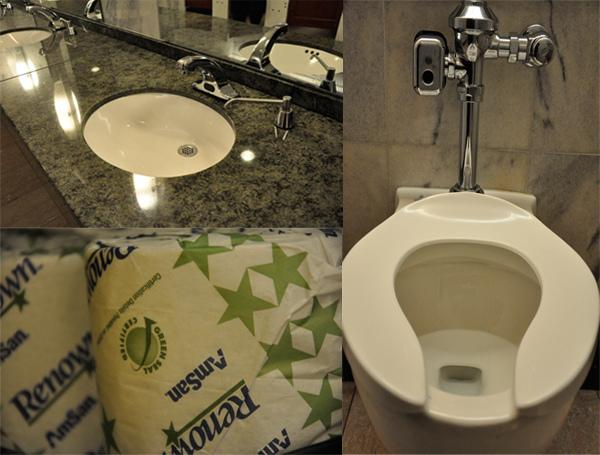How is the toilet flushed?

Choices:
A) pressure activated
B) ir beam
C) sound activated
D) manual handle ir beam 